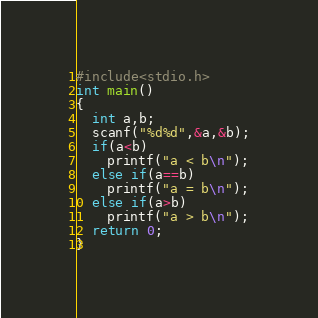Convert code to text. <code><loc_0><loc_0><loc_500><loc_500><_C_>#include<stdio.h>
int main()
{
  int a,b;
  scanf("%d%d",&a,&b);
  if(a<b)
    printf("a < b\n");
  else if(a==b)
    printf("a = b\n");
  else if(a>b)
    printf("a > b\n");
  return 0;
}</code> 